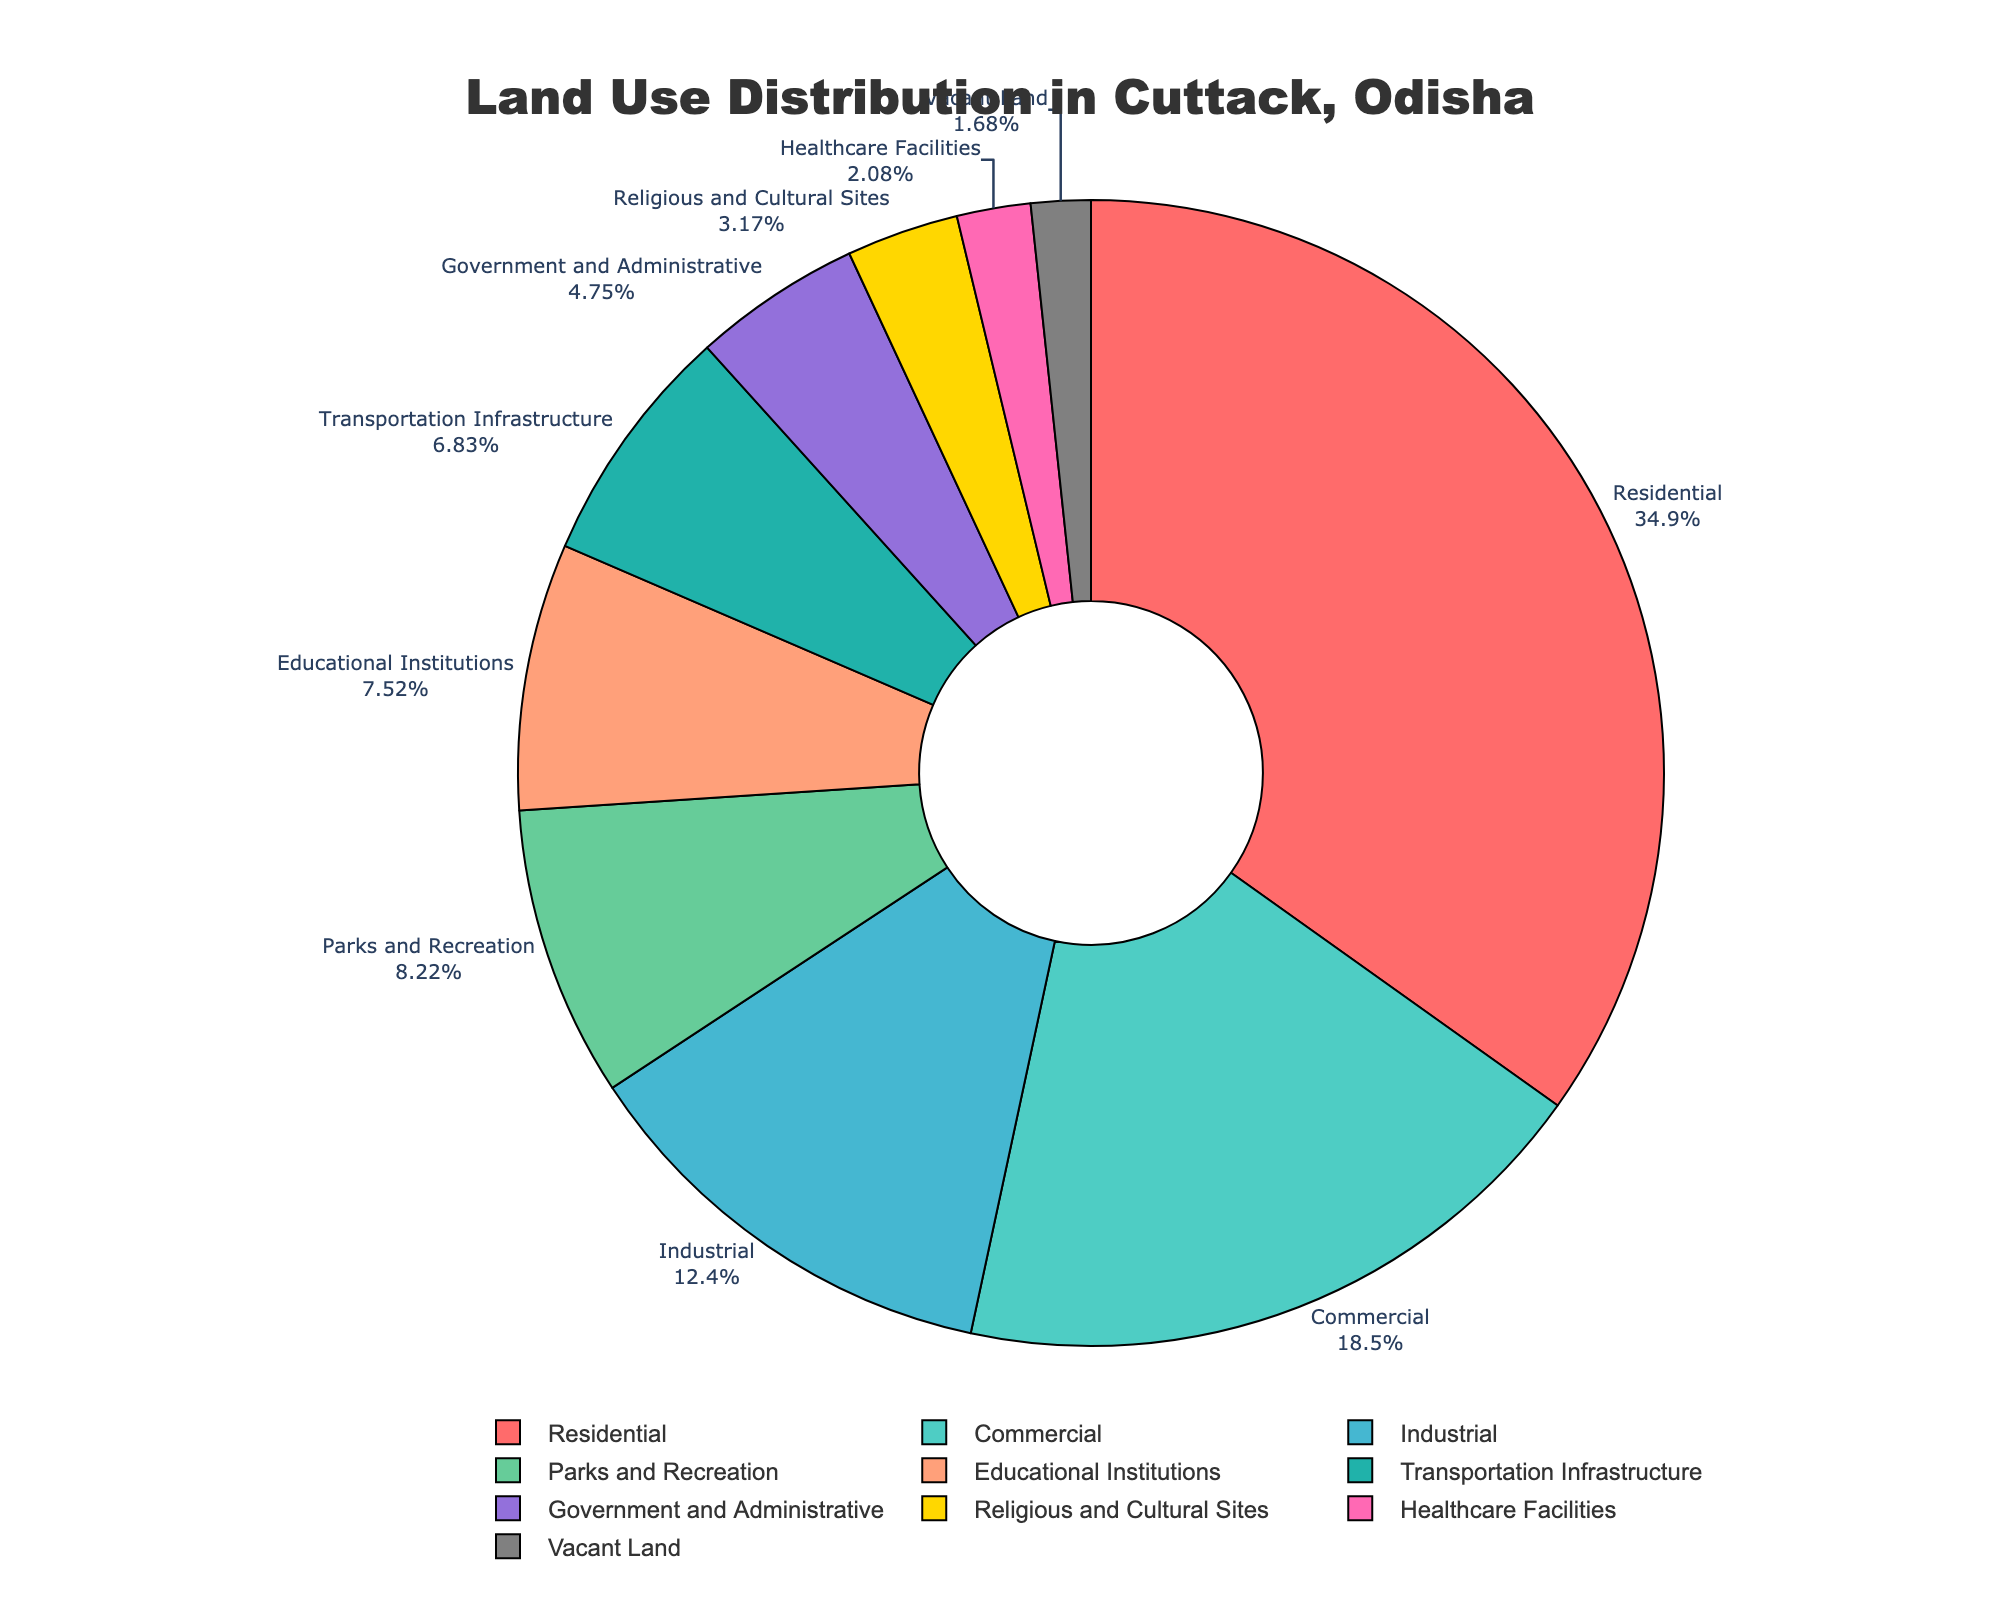Which land use type occupies the largest percentage in Cuttack, Odisha? The pie chart shows various land use types and their corresponding percentages. The largest slice represents the category with the highest percentage. Here, the largest slice is labeled "Residential" with 35.2%.
Answer: Residential Which category has the smallest land use percentage? By observing the slices and their labels, the smallest percentage shown is for "Vacant Land" at 1.7%.
Answer: Vacant Land What is the combined percentage of land used for Commercial and Industrial purposes? To find the combined percentage, add the percentages of Commercial and Industrial categories: 18.7% + 12.5% = 31.2%.
Answer: 31.2% Is the percentage of land used for Parks and Recreation higher than Educational Institutions? Comparing the two categories' percentages, Parks and Recreation is 8.3%, and Educational Institutions is 7.6%. Since 8.3% > 7.6%, Parks and Recreation has a higher percentage.
Answer: Yes Which category between Government and Administrative, and Transportation Infrastructure occupies more land? The percentage for Government and Administrative is 4.8%, while Transportation Infrastructure occupies 6.9%. Since 6.9% > 4.8%, Transportation Infrastructure occupies more land.
Answer: Transportation Infrastructure How much more land is used for Residential compared to Healthcare Facilities? To find the difference, subtract the percentage of Healthcare Facilities from Residential: 35.2% - 2.1% = 33.1%.
Answer: 33.1% What is the total percentage occupied by Religious and Cultural Sites, and Healthcare Facilities combined? Adding the percentages of Religious and Cultural Sites and Healthcare Facilities: 3.2% + 2.1% = 5.3%.
Answer: 5.3% By how much does the percentage of Industrial land use exceed that of Government and Administrative? Subtract the percentage of Government and Administrative from Industrial: 12.5% - 4.8% = 7.7%.
Answer: 7.7% If the percentage of Commercial land use were doubled, what would it be? Doubling the Commercial land use percentage: 18.7% * 2 = 37.4%.
Answer: 37.4% Which land use types are represented by shades of green in the pie chart? Observing the pie chart's color scheme, the shades of green correspond to Parks and Recreation and Transportation Infrastructure.
Answer: Parks and Recreation, Transportation Infrastructure 